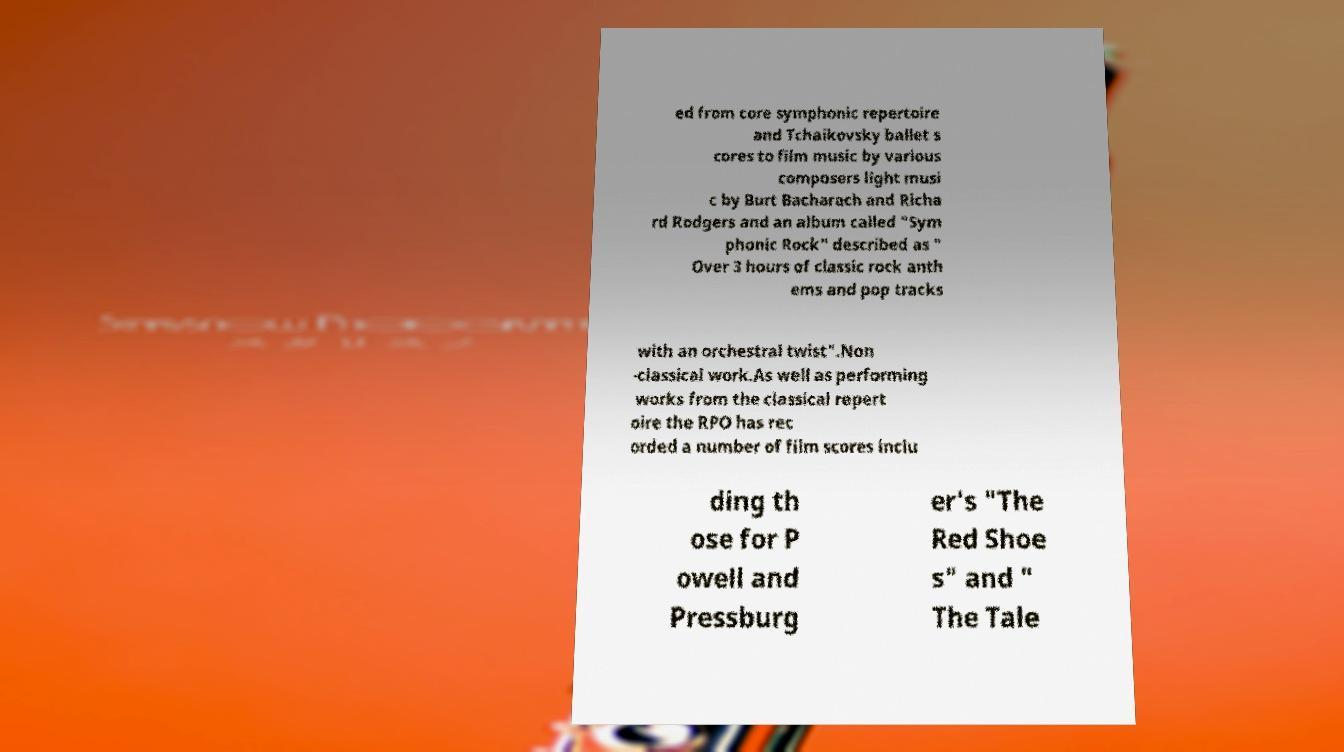Can you accurately transcribe the text from the provided image for me? ed from core symphonic repertoire and Tchaikovsky ballet s cores to film music by various composers light musi c by Burt Bacharach and Richa rd Rodgers and an album called "Sym phonic Rock" described as " Over 3 hours of classic rock anth ems and pop tracks with an orchestral twist".Non -classical work.As well as performing works from the classical repert oire the RPO has rec orded a number of film scores inclu ding th ose for P owell and Pressburg er's "The Red Shoe s" and " The Tale 